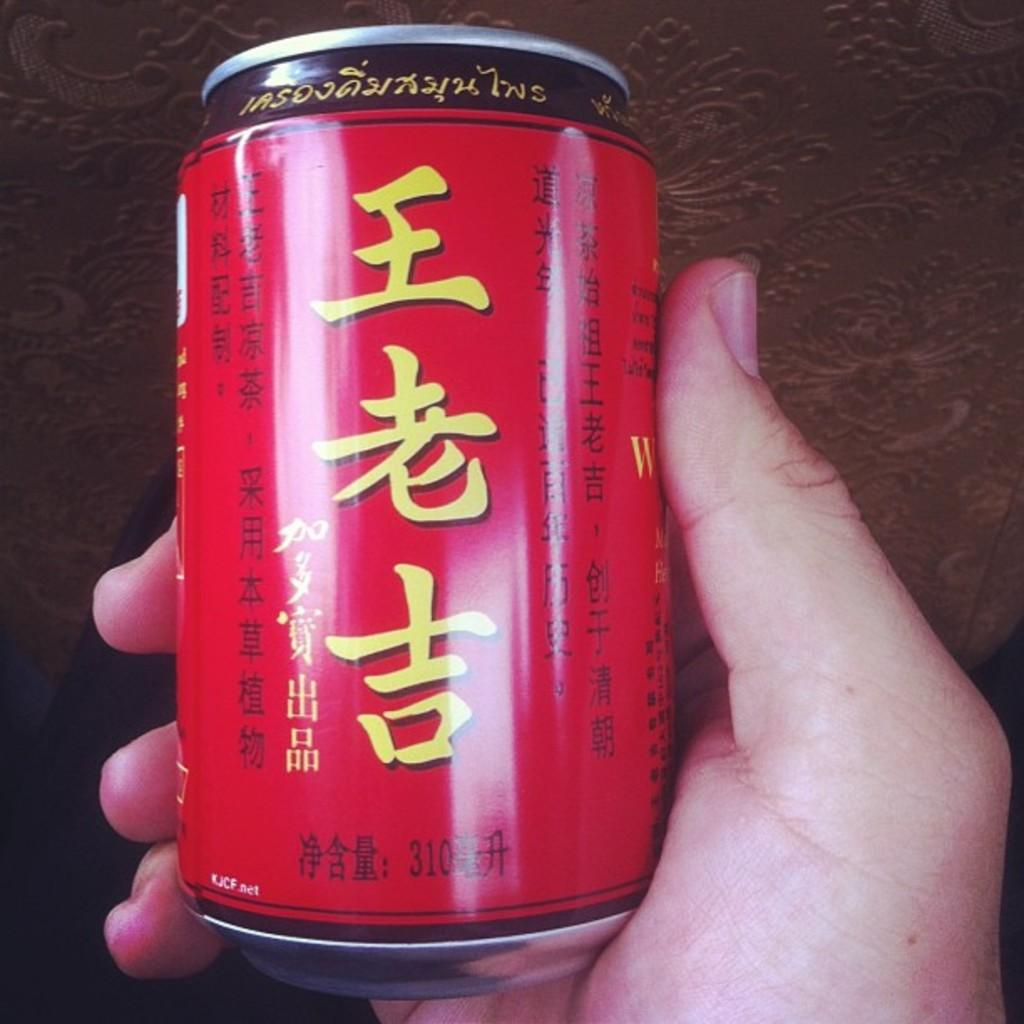<image>
Share a concise interpretation of the image provided. A red can with Chinese characters and a volume of 310, with a small KJCF.net text near the bottom. 